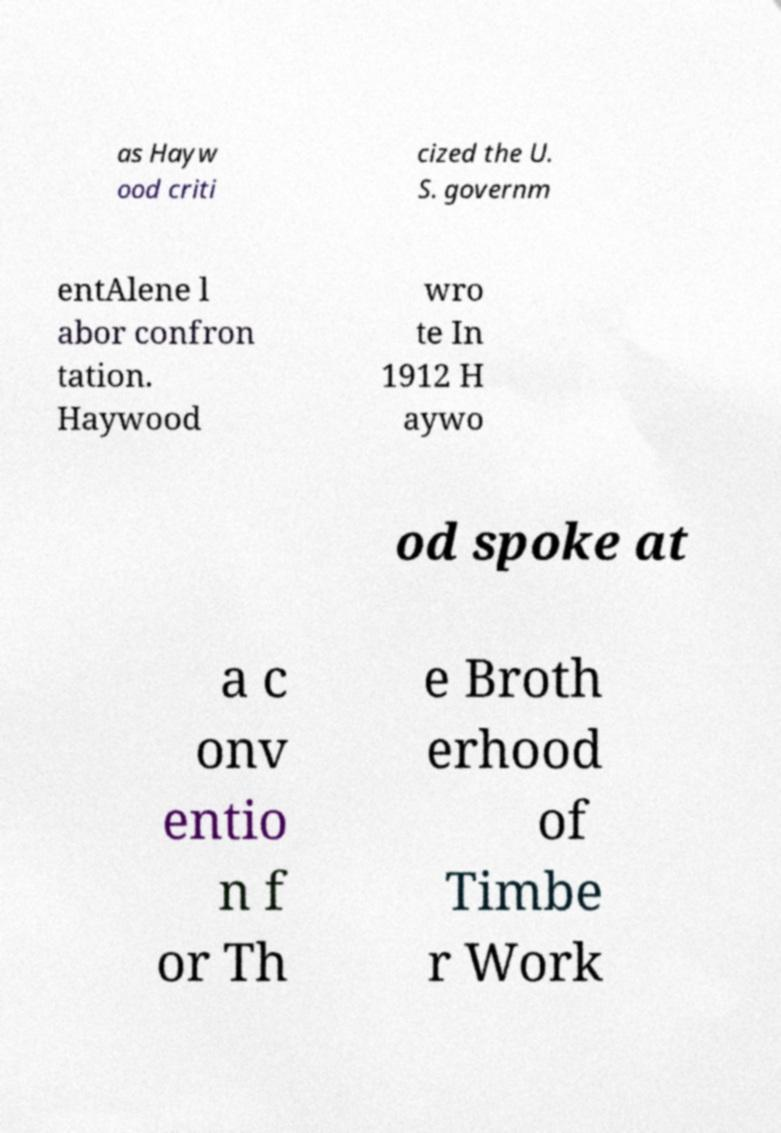Please identify and transcribe the text found in this image. as Hayw ood criti cized the U. S. governm entAlene l abor confron tation. Haywood wro te In 1912 H aywo od spoke at a c onv entio n f or Th e Broth erhood of Timbe r Work 